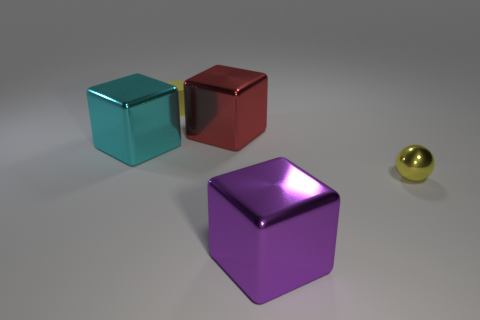What is the color of the cube that is in front of the thing to the right of the big purple metallic thing in front of the tiny yellow cylinder?
Keep it short and to the point. Purple. Is the cyan cube the same size as the purple metallic object?
Your answer should be very brief. Yes. Are there any other things that are the same shape as the tiny yellow matte thing?
Provide a succinct answer. No. What number of objects are either purple blocks on the right side of the large red shiny cube or yellow metal cylinders?
Provide a succinct answer. 1. Does the big red metal object have the same shape as the purple metal object?
Provide a succinct answer. Yes. How many other objects are the same size as the purple metal object?
Provide a short and direct response. 2. What color is the cylinder?
Give a very brief answer. Yellow. How many tiny things are brown metallic objects or yellow cylinders?
Ensure brevity in your answer.  1. There is a metal thing that is to the right of the purple metal block; does it have the same size as the block that is on the left side of the red metallic object?
Provide a succinct answer. No. The cyan object that is the same shape as the big purple thing is what size?
Your answer should be very brief. Large. 